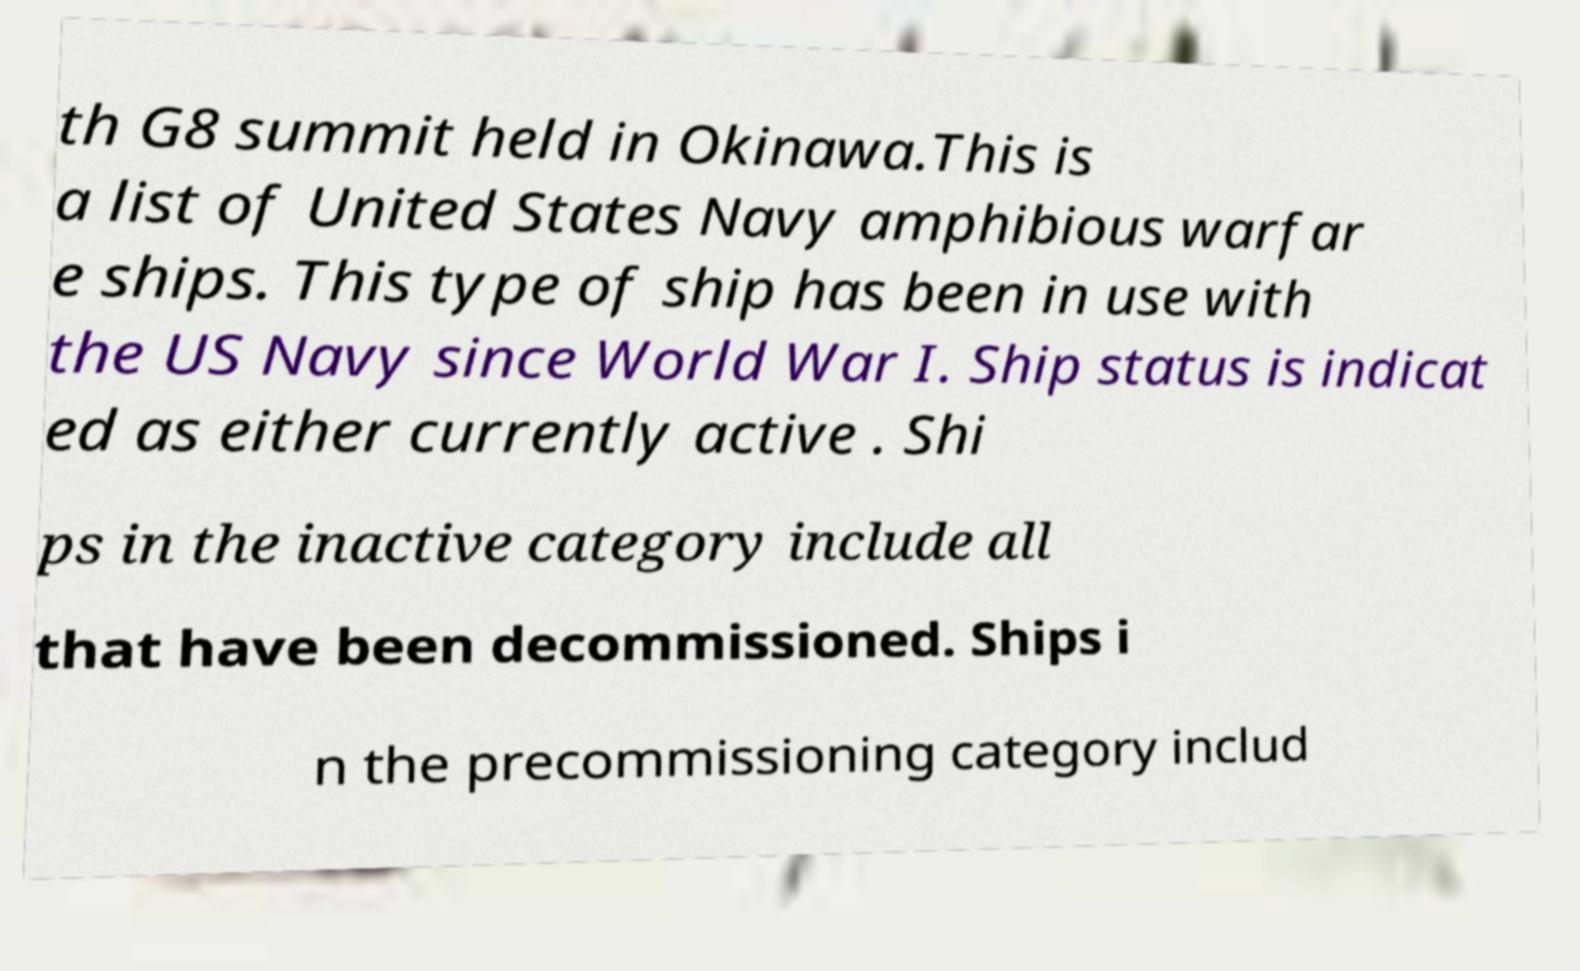What messages or text are displayed in this image? I need them in a readable, typed format. th G8 summit held in Okinawa.This is a list of United States Navy amphibious warfar e ships. This type of ship has been in use with the US Navy since World War I. Ship status is indicat ed as either currently active . Shi ps in the inactive category include all that have been decommissioned. Ships i n the precommissioning category includ 